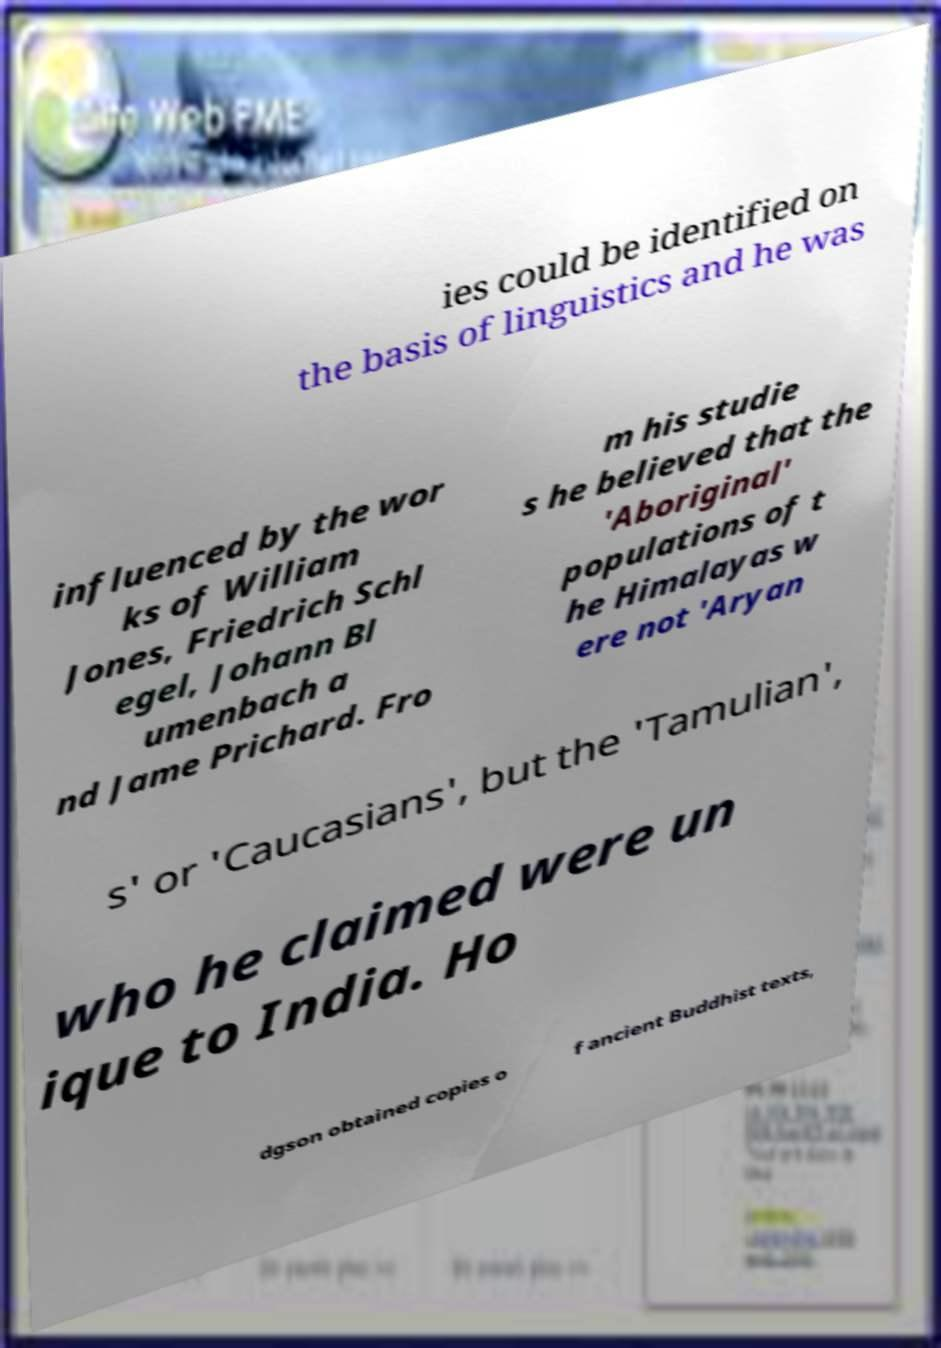Can you accurately transcribe the text from the provided image for me? ies could be identified on the basis of linguistics and he was influenced by the wor ks of William Jones, Friedrich Schl egel, Johann Bl umenbach a nd Jame Prichard. Fro m his studie s he believed that the 'Aboriginal' populations of t he Himalayas w ere not 'Aryan s' or 'Caucasians', but the 'Tamulian', who he claimed were un ique to India. Ho dgson obtained copies o f ancient Buddhist texts, 